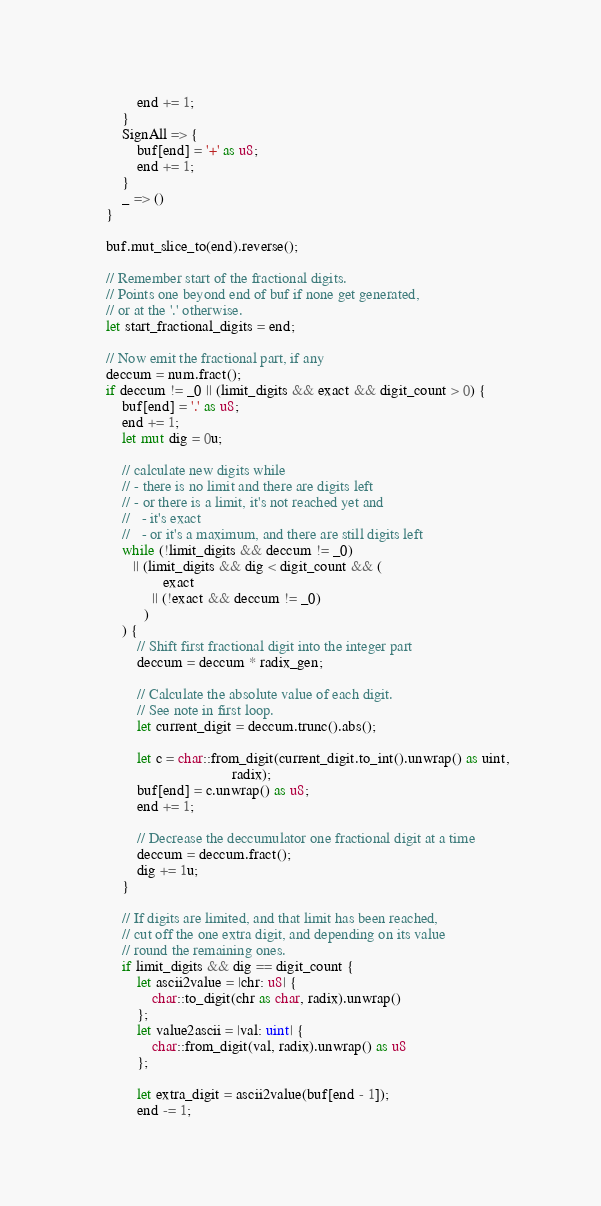Convert code to text. <code><loc_0><loc_0><loc_500><loc_500><_Rust_>            end += 1;
        }
        SignAll => {
            buf[end] = '+' as u8;
            end += 1;
        }
        _ => ()
    }

    buf.mut_slice_to(end).reverse();

    // Remember start of the fractional digits.
    // Points one beyond end of buf if none get generated,
    // or at the '.' otherwise.
    let start_fractional_digits = end;

    // Now emit the fractional part, if any
    deccum = num.fract();
    if deccum != _0 || (limit_digits && exact && digit_count > 0) {
        buf[end] = '.' as u8;
        end += 1;
        let mut dig = 0u;

        // calculate new digits while
        // - there is no limit and there are digits left
        // - or there is a limit, it's not reached yet and
        //   - it's exact
        //   - or it's a maximum, and there are still digits left
        while (!limit_digits && deccum != _0)
           || (limit_digits && dig < digit_count && (
                   exact
                || (!exact && deccum != _0)
              )
        ) {
            // Shift first fractional digit into the integer part
            deccum = deccum * radix_gen;

            // Calculate the absolute value of each digit.
            // See note in first loop.
            let current_digit = deccum.trunc().abs();

            let c = char::from_digit(current_digit.to_int().unwrap() as uint,
                                     radix);
            buf[end] = c.unwrap() as u8;
            end += 1;

            // Decrease the deccumulator one fractional digit at a time
            deccum = deccum.fract();
            dig += 1u;
        }

        // If digits are limited, and that limit has been reached,
        // cut off the one extra digit, and depending on its value
        // round the remaining ones.
        if limit_digits && dig == digit_count {
            let ascii2value = |chr: u8| {
                char::to_digit(chr as char, radix).unwrap()
            };
            let value2ascii = |val: uint| {
                char::from_digit(val, radix).unwrap() as u8
            };

            let extra_digit = ascii2value(buf[end - 1]);
            end -= 1;</code> 